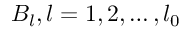<formula> <loc_0><loc_0><loc_500><loc_500>B _ { l } , l = 1 , 2 , \dots , l _ { 0 }</formula> 